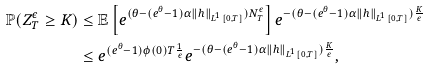<formula> <loc_0><loc_0><loc_500><loc_500>\mathbb { P } ( Z _ { T } ^ { \epsilon } \geq K ) & \leq \mathbb { E } \left [ e ^ { ( \theta - ( e ^ { \theta } - 1 ) \alpha \| h \| _ { L ^ { 1 } [ 0 , T ] } ) N _ { T } ^ { \epsilon } } \right ] e ^ { - ( \theta - ( e ^ { \theta } - 1 ) \alpha \| h \| _ { L ^ { 1 } [ 0 , T ] } ) \frac { K } { \epsilon } } \\ & \leq e ^ { ( e ^ { \theta } - 1 ) \phi ( 0 ) T \frac { 1 } { \epsilon } } e ^ { - ( \theta - ( e ^ { \theta } - 1 ) \alpha \| h \| _ { L ^ { 1 } [ 0 , T ] } ) \frac { K } { \epsilon } } ,</formula> 